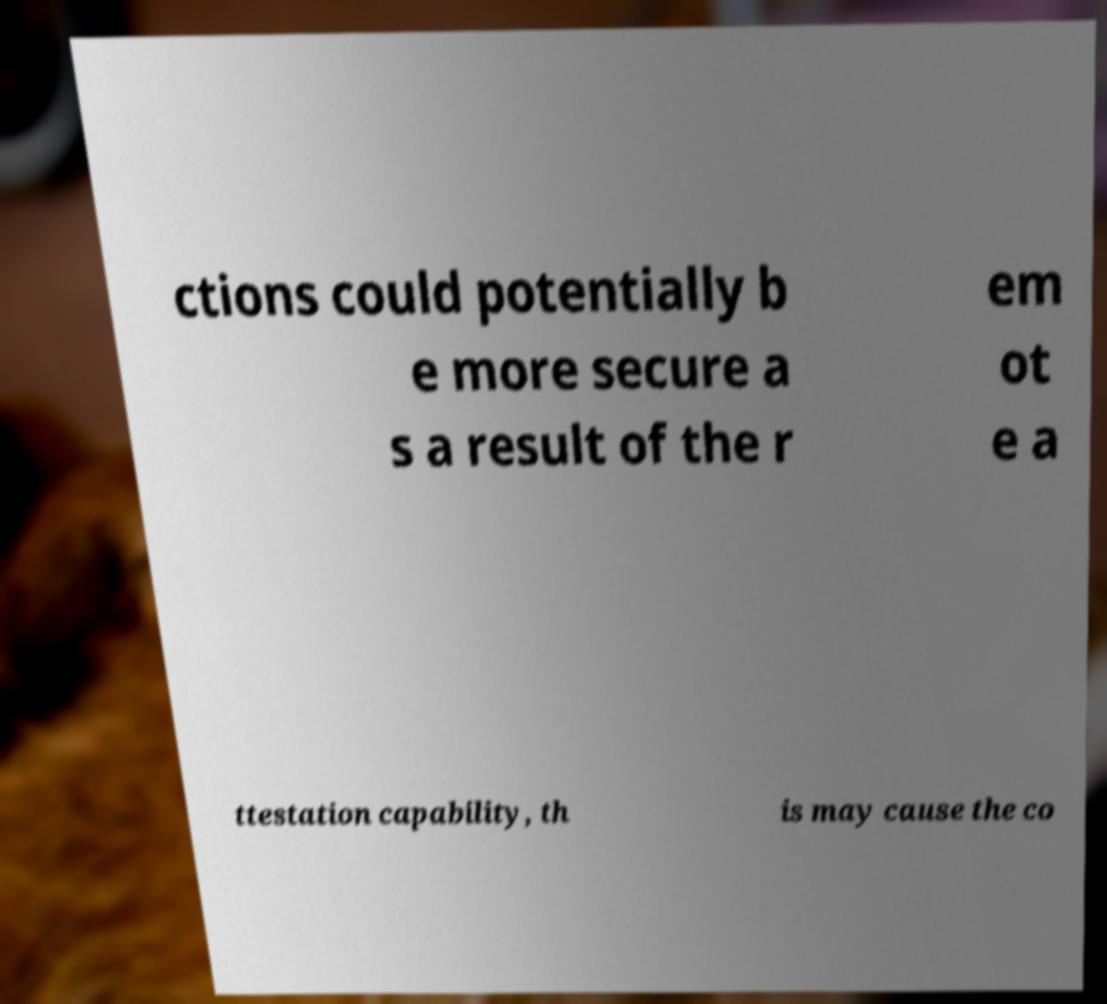Could you assist in decoding the text presented in this image and type it out clearly? ctions could potentially b e more secure a s a result of the r em ot e a ttestation capability, th is may cause the co 